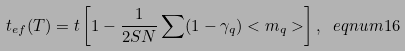<formula> <loc_0><loc_0><loc_500><loc_500>t _ { e f } ( T ) = t \left [ 1 - \frac { 1 } { 2 S N } \sum ( 1 - \gamma _ { q } ) < m _ { q } > \right ] , \ e q n u m { 1 6 }</formula> 